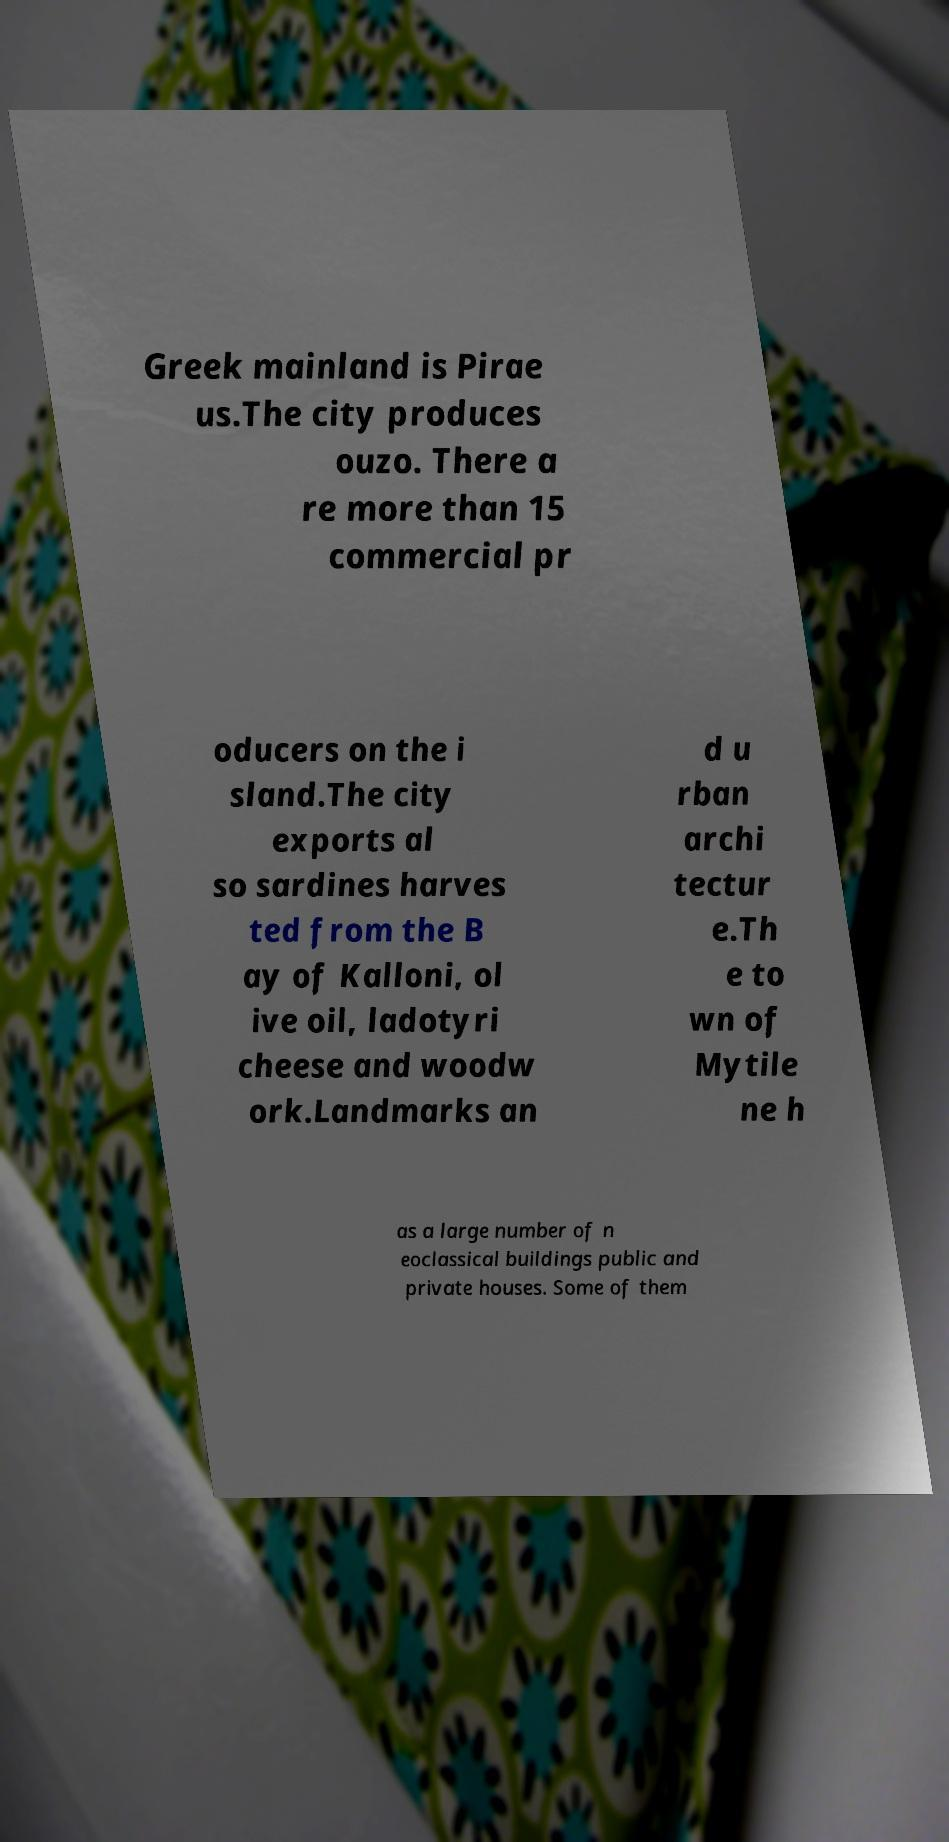Please identify and transcribe the text found in this image. Greek mainland is Pirae us.The city produces ouzo. There a re more than 15 commercial pr oducers on the i sland.The city exports al so sardines harves ted from the B ay of Kalloni, ol ive oil, ladotyri cheese and woodw ork.Landmarks an d u rban archi tectur e.Th e to wn of Mytile ne h as a large number of n eoclassical buildings public and private houses. Some of them 